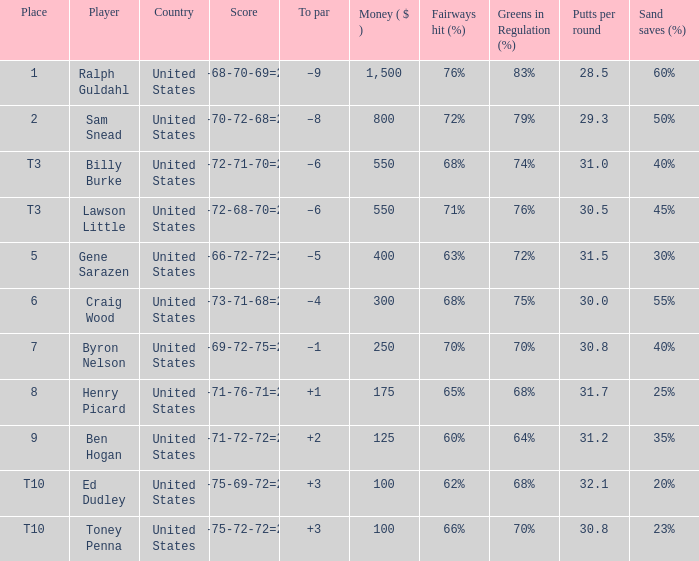Which country has a prize smaller than $250 and the player Henry Picard? United States. 